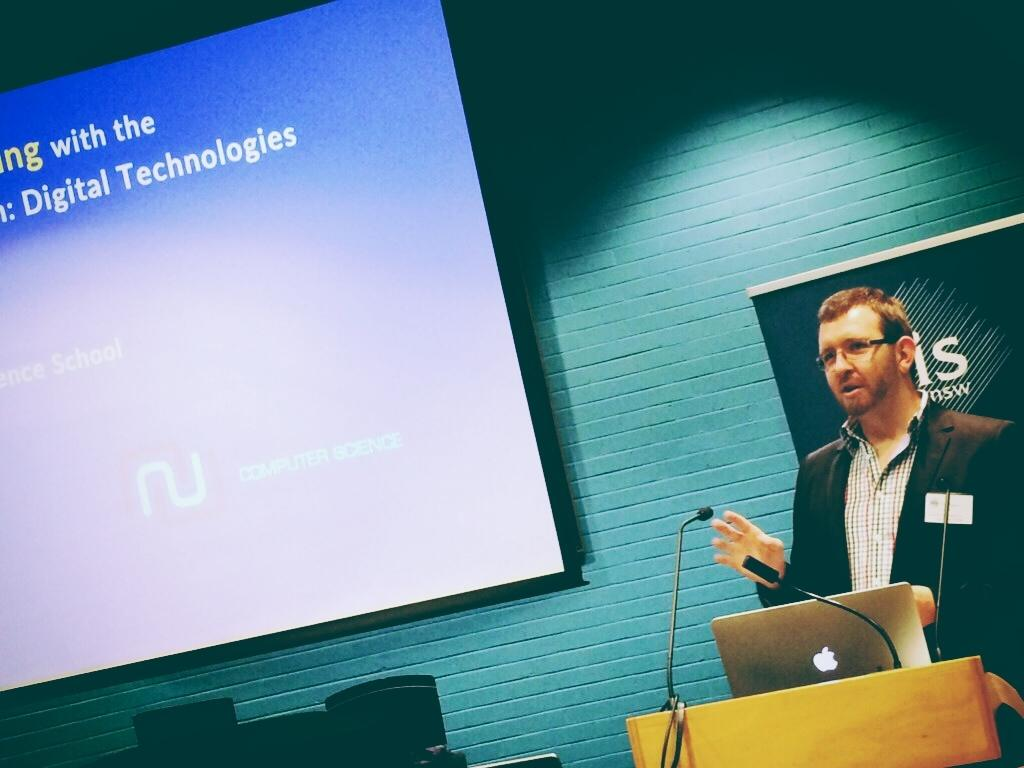Who or what is the main subject in the image? There is a person in the image. What object is on the podium in the image? There is a laptop on a podium in the image. What is the purpose of the projector screen in the image? The projector screen is likely used for presentations or displaying visuals. What can be seen in the background of the image? There is a wall in the background of the image. What type of vest is the girl wearing in the image? There is no girl or vest present in the image. 